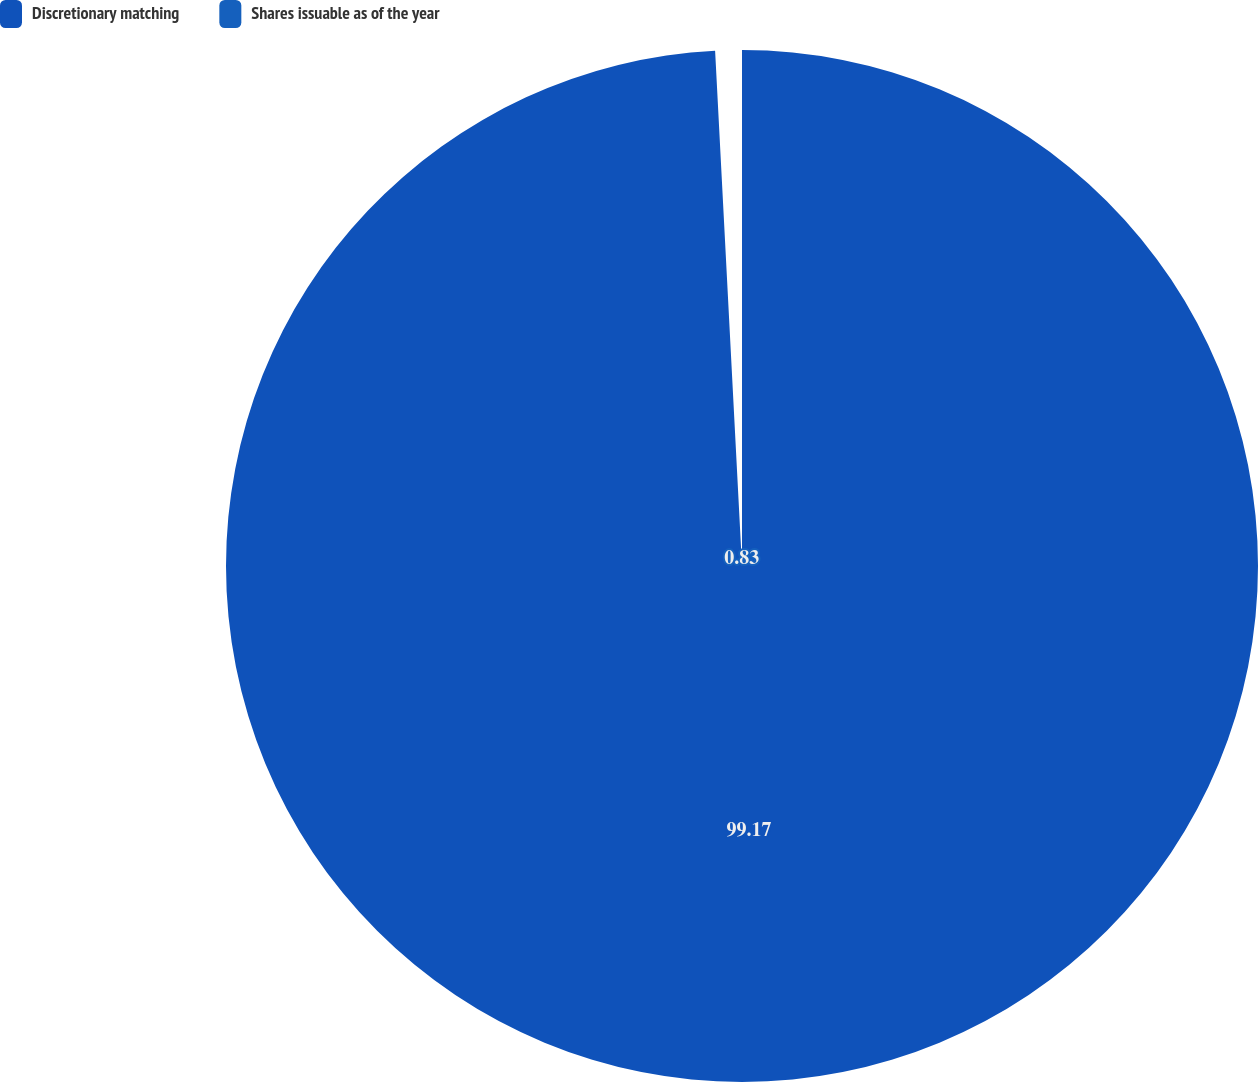Convert chart. <chart><loc_0><loc_0><loc_500><loc_500><pie_chart><fcel>Discretionary matching<fcel>Shares issuable as of the year<nl><fcel>99.17%<fcel>0.83%<nl></chart> 